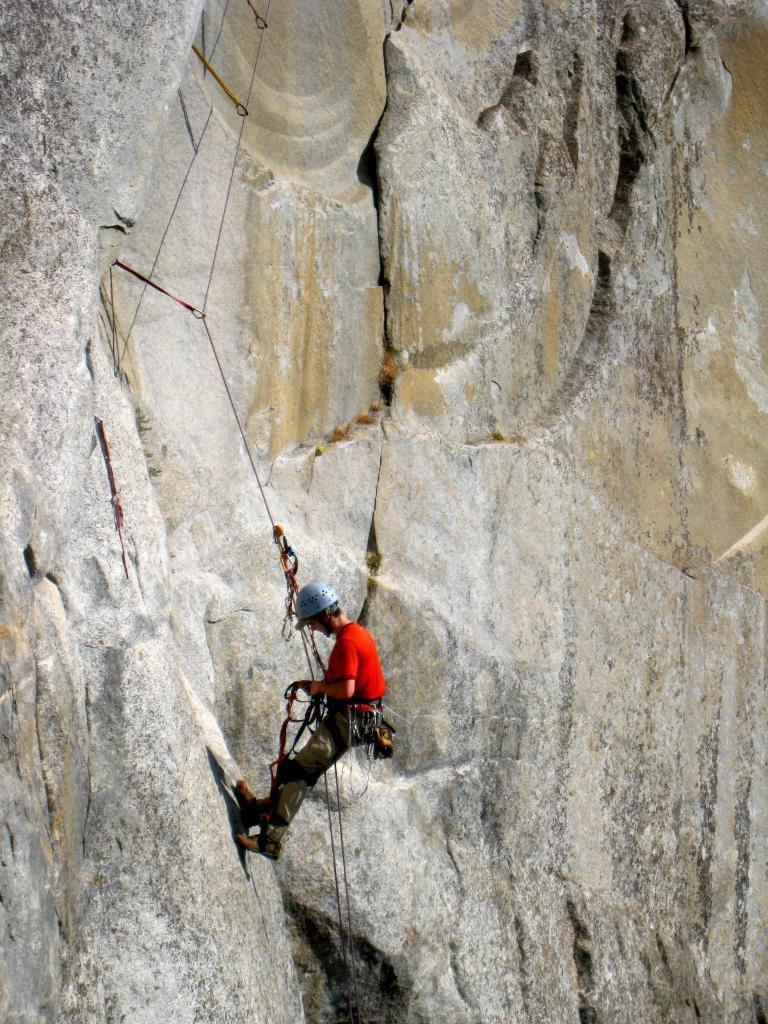What is the main subject of the image? There is a person in the image. What type of clothing is the person wearing? The person is wearing a t-shirt and trousers. What is the person holding in the image? The person is holding ropes. What activity is the person engaged in? The person is climbing a rock. What type of thunder can be heard in the image? There is no thunder present in the image, as it is a visual representation and does not include sound. 